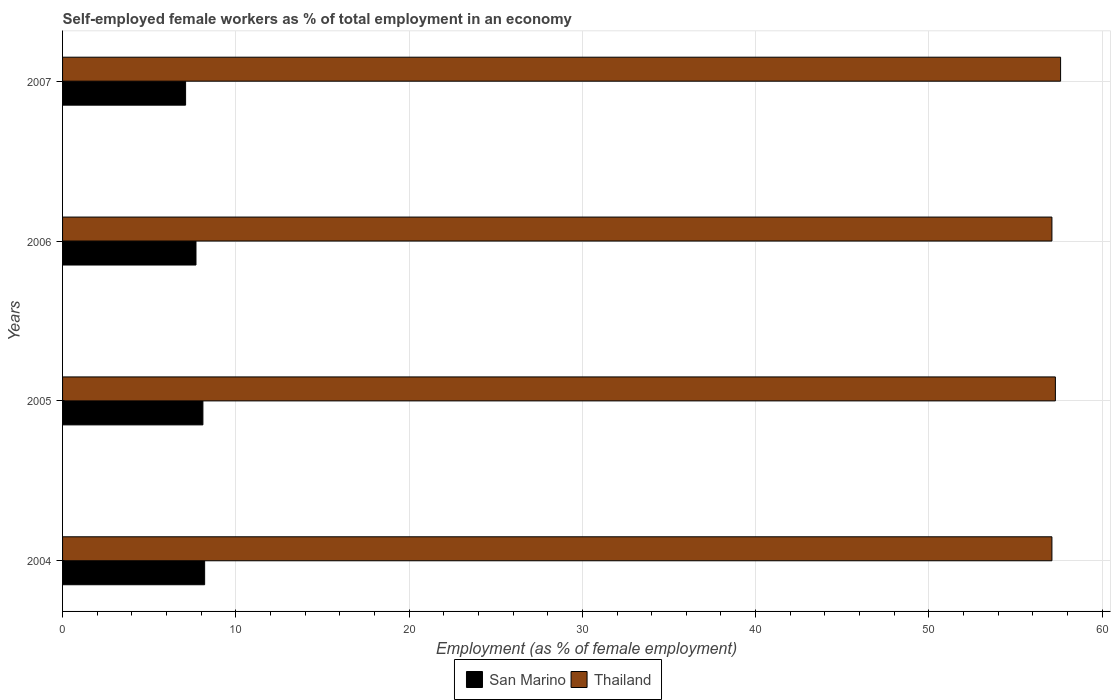How many different coloured bars are there?
Offer a very short reply. 2. How many groups of bars are there?
Offer a terse response. 4. How many bars are there on the 1st tick from the top?
Your response must be concise. 2. How many bars are there on the 4th tick from the bottom?
Offer a very short reply. 2. What is the label of the 3rd group of bars from the top?
Give a very brief answer. 2005. What is the percentage of self-employed female workers in San Marino in 2007?
Provide a succinct answer. 7.1. Across all years, what is the maximum percentage of self-employed female workers in Thailand?
Make the answer very short. 57.6. Across all years, what is the minimum percentage of self-employed female workers in Thailand?
Your answer should be compact. 57.1. In which year was the percentage of self-employed female workers in Thailand maximum?
Provide a succinct answer. 2007. In which year was the percentage of self-employed female workers in San Marino minimum?
Make the answer very short. 2007. What is the total percentage of self-employed female workers in Thailand in the graph?
Offer a terse response. 229.1. What is the difference between the percentage of self-employed female workers in Thailand in 2004 and that in 2007?
Offer a very short reply. -0.5. What is the difference between the percentage of self-employed female workers in San Marino in 2006 and the percentage of self-employed female workers in Thailand in 2007?
Keep it short and to the point. -49.9. What is the average percentage of self-employed female workers in Thailand per year?
Offer a terse response. 57.27. In the year 2006, what is the difference between the percentage of self-employed female workers in Thailand and percentage of self-employed female workers in San Marino?
Provide a short and direct response. 49.4. What is the ratio of the percentage of self-employed female workers in San Marino in 2006 to that in 2007?
Offer a very short reply. 1.08. Is the percentage of self-employed female workers in San Marino in 2004 less than that in 2007?
Ensure brevity in your answer.  No. Is the difference between the percentage of self-employed female workers in Thailand in 2005 and 2007 greater than the difference between the percentage of self-employed female workers in San Marino in 2005 and 2007?
Offer a terse response. No. What is the difference between the highest and the second highest percentage of self-employed female workers in Thailand?
Provide a short and direct response. 0.3. What is the difference between the highest and the lowest percentage of self-employed female workers in San Marino?
Make the answer very short. 1.1. Is the sum of the percentage of self-employed female workers in San Marino in 2004 and 2006 greater than the maximum percentage of self-employed female workers in Thailand across all years?
Your answer should be compact. No. What does the 1st bar from the top in 2006 represents?
Ensure brevity in your answer.  Thailand. What does the 2nd bar from the bottom in 2007 represents?
Your response must be concise. Thailand. How many bars are there?
Make the answer very short. 8. Are all the bars in the graph horizontal?
Your answer should be very brief. Yes. How many years are there in the graph?
Offer a terse response. 4. Are the values on the major ticks of X-axis written in scientific E-notation?
Offer a very short reply. No. Does the graph contain any zero values?
Provide a succinct answer. No. Does the graph contain grids?
Give a very brief answer. Yes. How many legend labels are there?
Ensure brevity in your answer.  2. How are the legend labels stacked?
Offer a terse response. Horizontal. What is the title of the graph?
Your response must be concise. Self-employed female workers as % of total employment in an economy. What is the label or title of the X-axis?
Ensure brevity in your answer.  Employment (as % of female employment). What is the label or title of the Y-axis?
Make the answer very short. Years. What is the Employment (as % of female employment) in San Marino in 2004?
Ensure brevity in your answer.  8.2. What is the Employment (as % of female employment) of Thailand in 2004?
Ensure brevity in your answer.  57.1. What is the Employment (as % of female employment) in San Marino in 2005?
Keep it short and to the point. 8.1. What is the Employment (as % of female employment) in Thailand in 2005?
Offer a very short reply. 57.3. What is the Employment (as % of female employment) in San Marino in 2006?
Your response must be concise. 7.7. What is the Employment (as % of female employment) of Thailand in 2006?
Make the answer very short. 57.1. What is the Employment (as % of female employment) of San Marino in 2007?
Your answer should be compact. 7.1. What is the Employment (as % of female employment) of Thailand in 2007?
Give a very brief answer. 57.6. Across all years, what is the maximum Employment (as % of female employment) of San Marino?
Make the answer very short. 8.2. Across all years, what is the maximum Employment (as % of female employment) of Thailand?
Your response must be concise. 57.6. Across all years, what is the minimum Employment (as % of female employment) of San Marino?
Ensure brevity in your answer.  7.1. Across all years, what is the minimum Employment (as % of female employment) of Thailand?
Give a very brief answer. 57.1. What is the total Employment (as % of female employment) of San Marino in the graph?
Your answer should be compact. 31.1. What is the total Employment (as % of female employment) in Thailand in the graph?
Ensure brevity in your answer.  229.1. What is the difference between the Employment (as % of female employment) of San Marino in 2004 and that in 2005?
Give a very brief answer. 0.1. What is the difference between the Employment (as % of female employment) of Thailand in 2004 and that in 2005?
Offer a very short reply. -0.2. What is the difference between the Employment (as % of female employment) of Thailand in 2004 and that in 2006?
Your response must be concise. 0. What is the difference between the Employment (as % of female employment) in San Marino in 2004 and that in 2007?
Offer a very short reply. 1.1. What is the difference between the Employment (as % of female employment) of Thailand in 2004 and that in 2007?
Ensure brevity in your answer.  -0.5. What is the difference between the Employment (as % of female employment) of Thailand in 2005 and that in 2006?
Offer a very short reply. 0.2. What is the difference between the Employment (as % of female employment) of San Marino in 2005 and that in 2007?
Ensure brevity in your answer.  1. What is the difference between the Employment (as % of female employment) in San Marino in 2004 and the Employment (as % of female employment) in Thailand in 2005?
Keep it short and to the point. -49.1. What is the difference between the Employment (as % of female employment) in San Marino in 2004 and the Employment (as % of female employment) in Thailand in 2006?
Offer a terse response. -48.9. What is the difference between the Employment (as % of female employment) in San Marino in 2004 and the Employment (as % of female employment) in Thailand in 2007?
Make the answer very short. -49.4. What is the difference between the Employment (as % of female employment) in San Marino in 2005 and the Employment (as % of female employment) in Thailand in 2006?
Offer a terse response. -49. What is the difference between the Employment (as % of female employment) of San Marino in 2005 and the Employment (as % of female employment) of Thailand in 2007?
Make the answer very short. -49.5. What is the difference between the Employment (as % of female employment) in San Marino in 2006 and the Employment (as % of female employment) in Thailand in 2007?
Make the answer very short. -49.9. What is the average Employment (as % of female employment) in San Marino per year?
Your answer should be compact. 7.78. What is the average Employment (as % of female employment) of Thailand per year?
Ensure brevity in your answer.  57.27. In the year 2004, what is the difference between the Employment (as % of female employment) of San Marino and Employment (as % of female employment) of Thailand?
Provide a succinct answer. -48.9. In the year 2005, what is the difference between the Employment (as % of female employment) in San Marino and Employment (as % of female employment) in Thailand?
Your response must be concise. -49.2. In the year 2006, what is the difference between the Employment (as % of female employment) in San Marino and Employment (as % of female employment) in Thailand?
Make the answer very short. -49.4. In the year 2007, what is the difference between the Employment (as % of female employment) of San Marino and Employment (as % of female employment) of Thailand?
Offer a terse response. -50.5. What is the ratio of the Employment (as % of female employment) in San Marino in 2004 to that in 2005?
Make the answer very short. 1.01. What is the ratio of the Employment (as % of female employment) of Thailand in 2004 to that in 2005?
Provide a short and direct response. 1. What is the ratio of the Employment (as % of female employment) of San Marino in 2004 to that in 2006?
Give a very brief answer. 1.06. What is the ratio of the Employment (as % of female employment) in Thailand in 2004 to that in 2006?
Give a very brief answer. 1. What is the ratio of the Employment (as % of female employment) in San Marino in 2004 to that in 2007?
Keep it short and to the point. 1.15. What is the ratio of the Employment (as % of female employment) of San Marino in 2005 to that in 2006?
Provide a succinct answer. 1.05. What is the ratio of the Employment (as % of female employment) in Thailand in 2005 to that in 2006?
Ensure brevity in your answer.  1. What is the ratio of the Employment (as % of female employment) in San Marino in 2005 to that in 2007?
Ensure brevity in your answer.  1.14. What is the ratio of the Employment (as % of female employment) of Thailand in 2005 to that in 2007?
Offer a very short reply. 0.99. What is the ratio of the Employment (as % of female employment) of San Marino in 2006 to that in 2007?
Make the answer very short. 1.08. What is the difference between the highest and the second highest Employment (as % of female employment) in San Marino?
Your response must be concise. 0.1. 